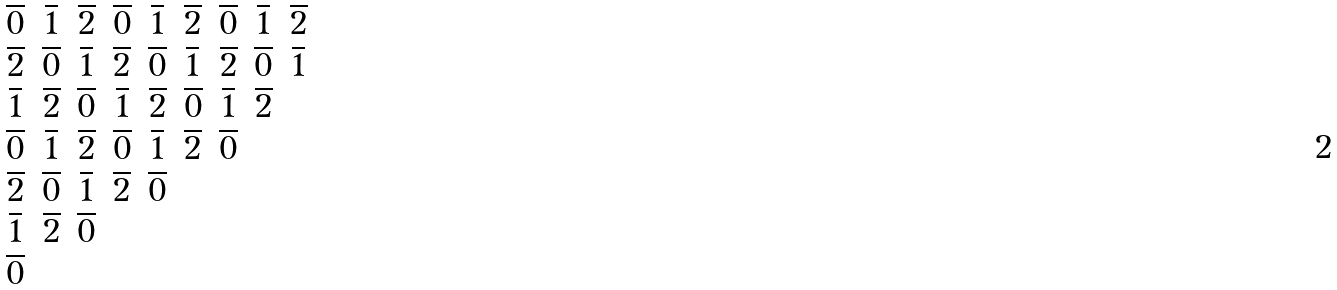<formula> <loc_0><loc_0><loc_500><loc_500>\begin{matrix} \overline { 0 } & \overline { 1 } & \overline { 2 } & \overline { 0 } & \overline { 1 } & \overline { 2 } & \overline { 0 } & \overline { 1 } & \overline { 2 } \\ \overline { 2 } & \overline { 0 } & \overline { 1 } & \overline { 2 } & \overline { 0 } & \overline { 1 } & \overline { 2 } & \overline { 0 } & \overline { 1 } \\ \overline { 1 } & \overline { 2 } & \overline { 0 } & \overline { 1 } & \overline { 2 } & \overline { 0 } & \overline { 1 } & \overline { 2 } & \\ \overline { 0 } & \overline { 1 } & \overline { 2 } & \overline { 0 } & \overline { 1 } & \overline { 2 } & \overline { 0 } & & \\ \overline { 2 } & \overline { 0 } & \overline { 1 } & \overline { 2 } & \overline { 0 } & & & & \\ \overline { 1 } & \overline { 2 } & \overline { 0 } & & & & & & \\ \overline { 0 } & & & & & & & & \end{matrix}</formula> 